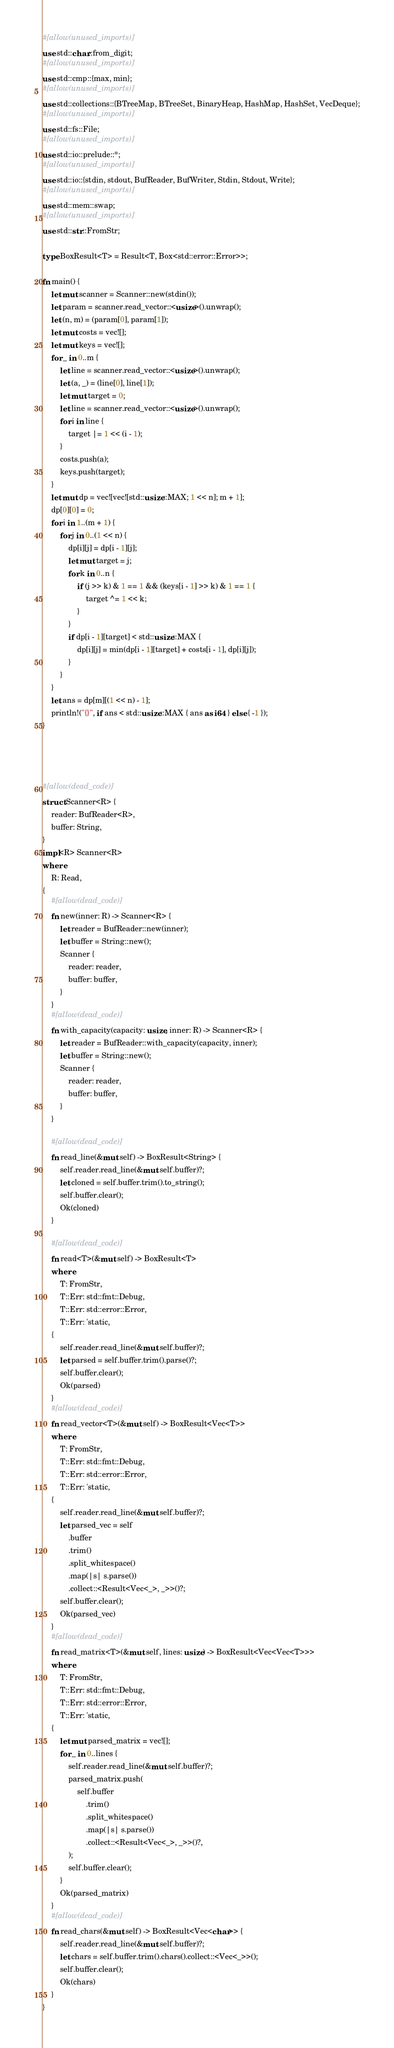<code> <loc_0><loc_0><loc_500><loc_500><_Rust_>#[allow(unused_imports)]
use std::char::from_digit;
#[allow(unused_imports)]
use std::cmp::{max, min};
#[allow(unused_imports)]
use std::collections::{BTreeMap, BTreeSet, BinaryHeap, HashMap, HashSet, VecDeque};
#[allow(unused_imports)]
use std::fs::File;
#[allow(unused_imports)]
use std::io::prelude::*;
#[allow(unused_imports)]
use std::io::{stdin, stdout, BufReader, BufWriter, Stdin, Stdout, Write};
#[allow(unused_imports)]
use std::mem::swap;
#[allow(unused_imports)]
use std::str::FromStr;

type BoxResult<T> = Result<T, Box<std::error::Error>>;

fn main() {
    let mut scanner = Scanner::new(stdin());
    let param = scanner.read_vector::<usize>().unwrap();
    let (n, m) = (param[0], param[1]);
    let mut costs = vec![];
    let mut keys = vec![];
    for _ in 0..m {
        let line = scanner.read_vector::<usize>().unwrap();
        let (a, _) = (line[0], line[1]);
        let mut target = 0;
        let line = scanner.read_vector::<usize>().unwrap();
        for i in line {
            target |= 1 << (i - 1);
        }
        costs.push(a);
        keys.push(target);
    }
    let mut dp = vec![vec![std::usize::MAX; 1 << n]; m + 1];
    dp[0][0] = 0;
    for i in 1..(m + 1) {
        for j in 0..(1 << n) {
            dp[i][j] = dp[i - 1][j];
            let mut target = j;
            for k in 0..n {
                if (j >> k) & 1 == 1 && (keys[i - 1] >> k) & 1 == 1 {
                    target ^= 1 << k;
                }
            }
            if dp[i - 1][target] < std::usize::MAX {
                dp[i][j] = min(dp[i - 1][target] + costs[i - 1], dp[i][j]);
            }
        }
    }
    let ans = dp[m][(1 << n) - 1];
    println!("{}", if ans < std::usize::MAX { ans as i64 } else { -1 });
}




#[allow(dead_code)]
struct Scanner<R> {
    reader: BufReader<R>,
    buffer: String,
}
impl<R> Scanner<R>
where
    R: Read,
{
    #[allow(dead_code)]
    fn new(inner: R) -> Scanner<R> {
        let reader = BufReader::new(inner);
        let buffer = String::new();
        Scanner {
            reader: reader,
            buffer: buffer,
        }
    }
    #[allow(dead_code)]
    fn with_capacity(capacity: usize, inner: R) -> Scanner<R> {
        let reader = BufReader::with_capacity(capacity, inner);
        let buffer = String::new();
        Scanner {
            reader: reader,
            buffer: buffer,
        }
    }

    #[allow(dead_code)]
    fn read_line(&mut self) -> BoxResult<String> {
        self.reader.read_line(&mut self.buffer)?;
        let cloned = self.buffer.trim().to_string();
        self.buffer.clear();
        Ok(cloned)
    }

    #[allow(dead_code)]
    fn read<T>(&mut self) -> BoxResult<T>
    where
        T: FromStr,
        T::Err: std::fmt::Debug,
        T::Err: std::error::Error,
        T::Err: 'static,
    {
        self.reader.read_line(&mut self.buffer)?;
        let parsed = self.buffer.trim().parse()?;
        self.buffer.clear();
        Ok(parsed)
    }
    #[allow(dead_code)]
    fn read_vector<T>(&mut self) -> BoxResult<Vec<T>>
    where
        T: FromStr,
        T::Err: std::fmt::Debug,
        T::Err: std::error::Error,
        T::Err: 'static,
    {
        self.reader.read_line(&mut self.buffer)?;
        let parsed_vec = self
            .buffer
            .trim()
            .split_whitespace()
            .map(|s| s.parse())
            .collect::<Result<Vec<_>, _>>()?;
        self.buffer.clear();
        Ok(parsed_vec)
    }
    #[allow(dead_code)]
    fn read_matrix<T>(&mut self, lines: usize) -> BoxResult<Vec<Vec<T>>>
    where
        T: FromStr,
        T::Err: std::fmt::Debug,
        T::Err: std::error::Error,
        T::Err: 'static,
    {
        let mut parsed_matrix = vec![];
        for _ in 0..lines {
            self.reader.read_line(&mut self.buffer)?;
            parsed_matrix.push(
                self.buffer
                    .trim()
                    .split_whitespace()
                    .map(|s| s.parse())
                    .collect::<Result<Vec<_>, _>>()?,
            );
            self.buffer.clear();
        }
        Ok(parsed_matrix)
    }
    #[allow(dead_code)]
    fn read_chars(&mut self) -> BoxResult<Vec<char>> {
        self.reader.read_line(&mut self.buffer)?;
        let chars = self.buffer.trim().chars().collect::<Vec<_>>();
        self.buffer.clear();
        Ok(chars)
    }
}
</code> 